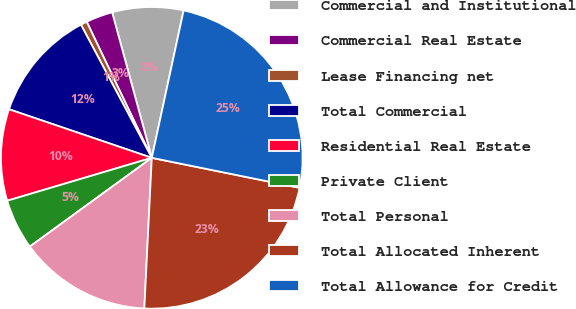<chart> <loc_0><loc_0><loc_500><loc_500><pie_chart><fcel>Commercial and Institutional<fcel>Commercial Real Estate<fcel>Lease Financing net<fcel>Total Commercial<fcel>Residential Real Estate<fcel>Private Client<fcel>Total Personal<fcel>Total Allocated Inherent<fcel>Total Allowance for Credit<nl><fcel>7.62%<fcel>2.87%<fcel>0.68%<fcel>12.0%<fcel>9.81%<fcel>5.42%<fcel>14.2%<fcel>22.6%<fcel>24.8%<nl></chart> 